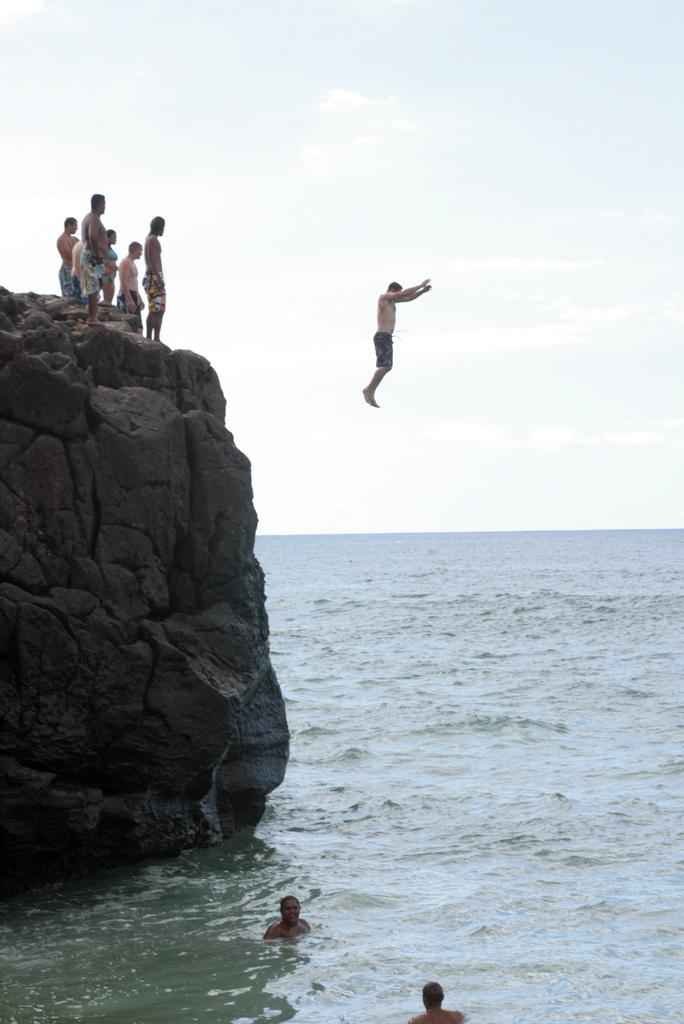What are the people in the image doing on the rock? There is a group of people standing on a rock in the image. What action is one person performing in the image? One person is jumping in the image. What activity are two people engaged in near the rock? Two people are swimming in the water near the rock. What can be seen in the background of the image? The sky is visible in the background of the image. What type of lamp is hanging above the swimmers in the image? There is no lamp present in the image; it features a group of people standing on a rock, one person jumping, and two people swimming in the water. What is the coach's opinion on the person jumping in the image? There is no coach present in the image, and therefore no opinion can be attributed to a coach. 